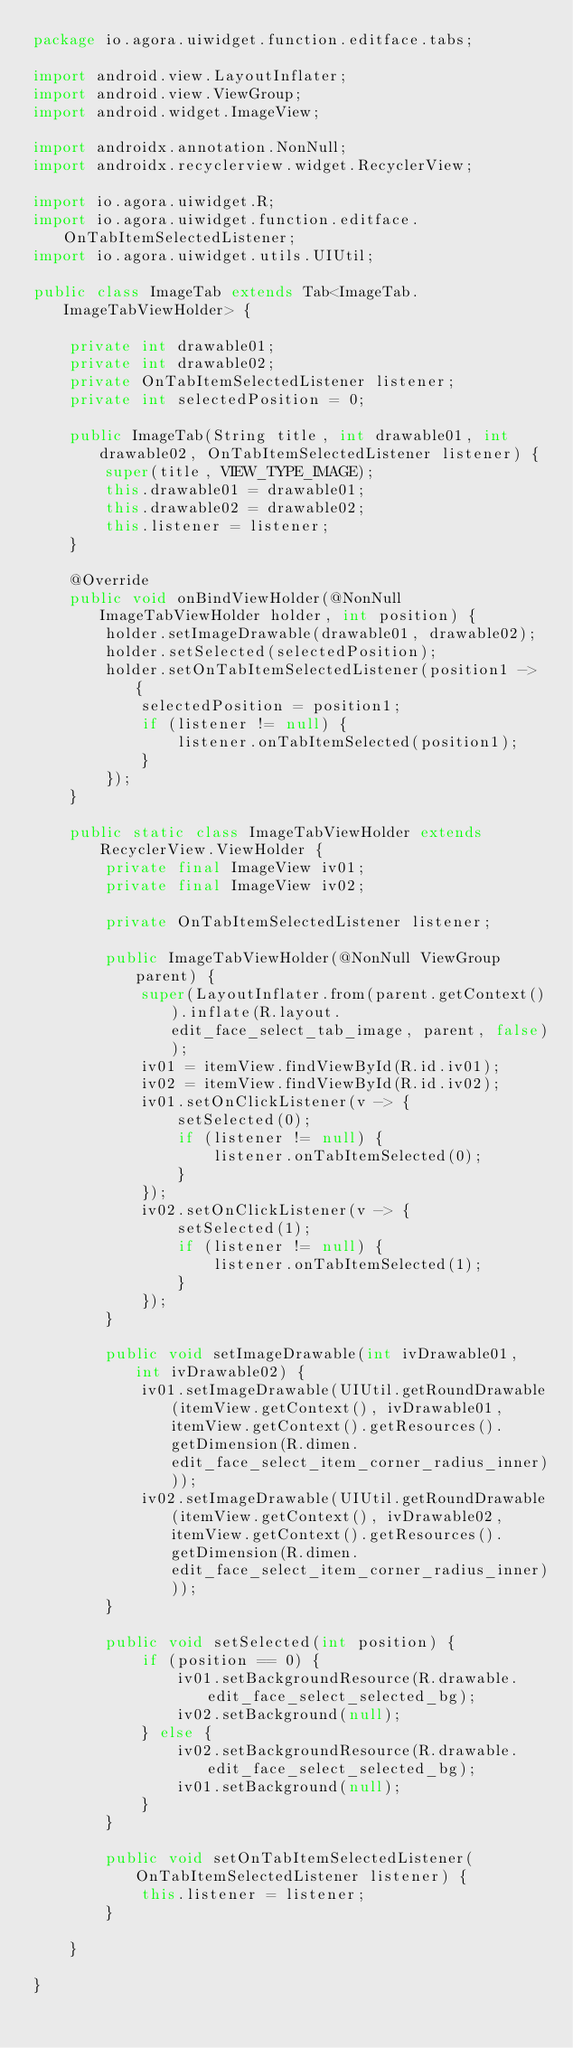<code> <loc_0><loc_0><loc_500><loc_500><_Java_>package io.agora.uiwidget.function.editface.tabs;

import android.view.LayoutInflater;
import android.view.ViewGroup;
import android.widget.ImageView;

import androidx.annotation.NonNull;
import androidx.recyclerview.widget.RecyclerView;

import io.agora.uiwidget.R;
import io.agora.uiwidget.function.editface.OnTabItemSelectedListener;
import io.agora.uiwidget.utils.UIUtil;

public class ImageTab extends Tab<ImageTab.ImageTabViewHolder> {

    private int drawable01;
    private int drawable02;
    private OnTabItemSelectedListener listener;
    private int selectedPosition = 0;

    public ImageTab(String title, int drawable01, int drawable02, OnTabItemSelectedListener listener) {
        super(title, VIEW_TYPE_IMAGE);
        this.drawable01 = drawable01;
        this.drawable02 = drawable02;
        this.listener = listener;
    }

    @Override
    public void onBindViewHolder(@NonNull ImageTabViewHolder holder, int position) {
        holder.setImageDrawable(drawable01, drawable02);
        holder.setSelected(selectedPosition);
        holder.setOnTabItemSelectedListener(position1 -> {
            selectedPosition = position1;
            if (listener != null) {
                listener.onTabItemSelected(position1);
            }
        });
    }

    public static class ImageTabViewHolder extends RecyclerView.ViewHolder {
        private final ImageView iv01;
        private final ImageView iv02;

        private OnTabItemSelectedListener listener;

        public ImageTabViewHolder(@NonNull ViewGroup parent) {
            super(LayoutInflater.from(parent.getContext()).inflate(R.layout.edit_face_select_tab_image, parent, false));
            iv01 = itemView.findViewById(R.id.iv01);
            iv02 = itemView.findViewById(R.id.iv02);
            iv01.setOnClickListener(v -> {
                setSelected(0);
                if (listener != null) {
                    listener.onTabItemSelected(0);
                }
            });
            iv02.setOnClickListener(v -> {
                setSelected(1);
                if (listener != null) {
                    listener.onTabItemSelected(1);
                }
            });
        }

        public void setImageDrawable(int ivDrawable01, int ivDrawable02) {
            iv01.setImageDrawable(UIUtil.getRoundDrawable(itemView.getContext(), ivDrawable01, itemView.getContext().getResources().getDimension(R.dimen.edit_face_select_item_corner_radius_inner)));
            iv02.setImageDrawable(UIUtil.getRoundDrawable(itemView.getContext(), ivDrawable02, itemView.getContext().getResources().getDimension(R.dimen.edit_face_select_item_corner_radius_inner)));
        }

        public void setSelected(int position) {
            if (position == 0) {
                iv01.setBackgroundResource(R.drawable.edit_face_select_selected_bg);
                iv02.setBackground(null);
            } else {
                iv02.setBackgroundResource(R.drawable.edit_face_select_selected_bg);
                iv01.setBackground(null);
            }
        }

        public void setOnTabItemSelectedListener(OnTabItemSelectedListener listener) {
            this.listener = listener;
        }

    }

}
</code> 